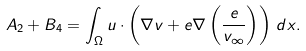<formula> <loc_0><loc_0><loc_500><loc_500>A _ { 2 } + B _ { 4 } = \int _ { \Omega } u \cdot \left ( \nabla v + e \nabla \left ( \frac { e } { v _ { \infty } } \right ) \right ) \, d x .</formula> 